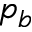Convert formula to latex. <formula><loc_0><loc_0><loc_500><loc_500>p _ { b }</formula> 